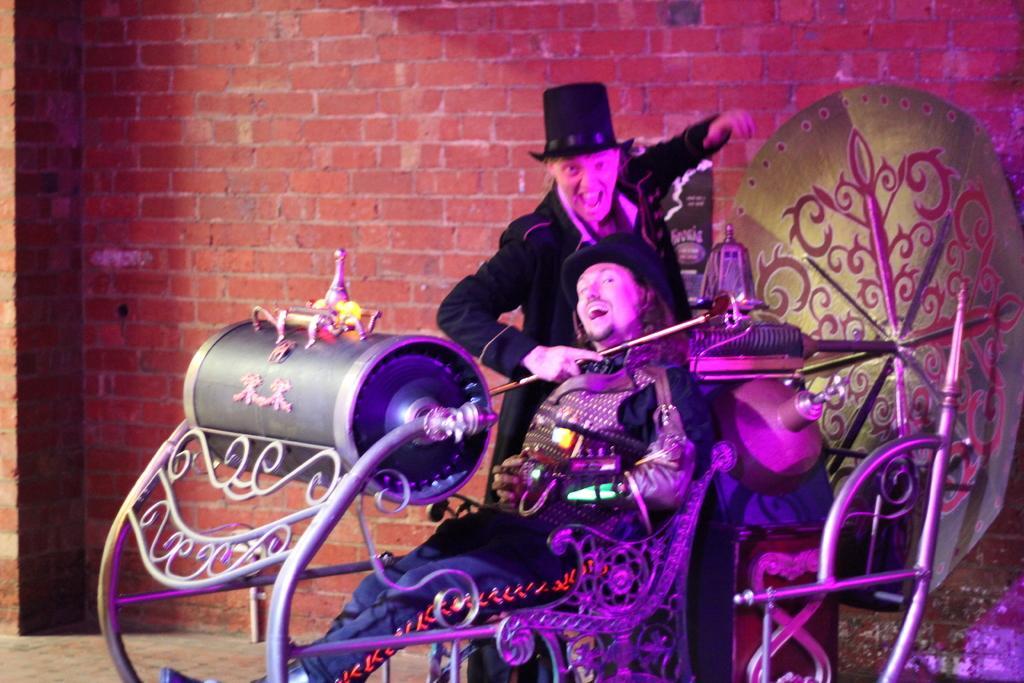How would you summarize this image in a sentence or two? In this image I see 2 persons in which this man is sitting and I see that he is wearing a costume and I see that both of them are wearing black color hats and I see that this person is holding a stick in his hand and in the background I see the brick wall. 